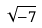Convert formula to latex. <formula><loc_0><loc_0><loc_500><loc_500>\sqrt { - 7 }</formula> 